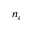<formula> <loc_0><loc_0><loc_500><loc_500>n _ { c }</formula> 